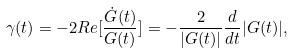Convert formula to latex. <formula><loc_0><loc_0><loc_500><loc_500>\gamma ( t ) = - 2 R e [ \frac { \dot { G } ( t ) } { G ( t ) } ] = - \frac { 2 } { | G ( t ) | } \frac { d } { d t } | G ( t ) | ,</formula> 